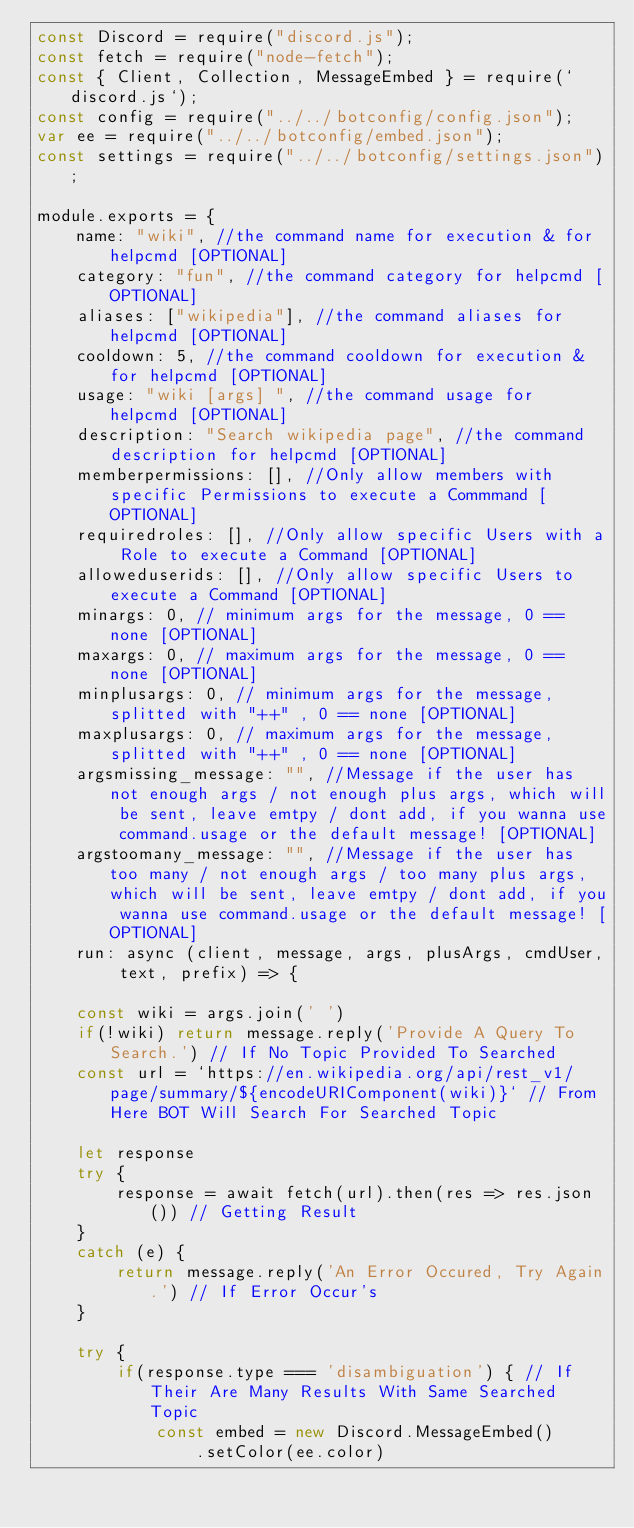Convert code to text. <code><loc_0><loc_0><loc_500><loc_500><_JavaScript_>const Discord = require("discord.js");
const fetch = require("node-fetch");
const { Client, Collection, MessageEmbed } = require(`discord.js`);
const config = require("../../botconfig/config.json");
var ee = require("../../botconfig/embed.json");
const settings = require("../../botconfig/settings.json");

module.exports = {
    name: "wiki", //the command name for execution & for helpcmd [OPTIONAL]
    category: "fun", //the command category for helpcmd [OPTIONAL]
    aliases: ["wikipedia"], //the command aliases for helpcmd [OPTIONAL]
    cooldown: 5, //the command cooldown for execution & for helpcmd [OPTIONAL]
    usage: "wiki [args] ", //the command usage for helpcmd [OPTIONAL]
    description: "Search wikipedia page", //the command description for helpcmd [OPTIONAL]
    memberpermissions: [], //Only allow members with specific Permissions to execute a Commmand [OPTIONAL]
    requiredroles: [], //Only allow specific Users with a Role to execute a Command [OPTIONAL]
    alloweduserids: [], //Only allow specific Users to execute a Command [OPTIONAL]
    minargs: 0, // minimum args for the message, 0 == none [OPTIONAL]
    maxargs: 0, // maximum args for the message, 0 == none [OPTIONAL]
    minplusargs: 0, // minimum args for the message, splitted with "++" , 0 == none [OPTIONAL]
    maxplusargs: 0, // maximum args for the message, splitted with "++" , 0 == none [OPTIONAL]
    argsmissing_message: "", //Message if the user has not enough args / not enough plus args, which will be sent, leave emtpy / dont add, if you wanna use command.usage or the default message! [OPTIONAL]
    argstoomany_message: "", //Message if the user has too many / not enough args / too many plus args, which will be sent, leave emtpy / dont add, if you wanna use command.usage or the default message! [OPTIONAL]
    run: async (client, message, args, plusArgs, cmdUser, text, prefix) => {
    
    const wiki = args.join(' ')
    if(!wiki) return message.reply('Provide A Query To Search.') // If No Topic Provided To Searched
    const url = `https://en.wikipedia.org/api/rest_v1/page/summary/${encodeURIComponent(wiki)}` // From Here BOT Will Search For Searched Topic

    let response
    try {
        response = await fetch(url).then(res => res.json()) // Getting Result
    }
    catch (e) {
        return message.reply('An Error Occured, Try Again.') // If Error Occur's
    }

    try {
        if(response.type === 'disambiguation') { // If Their Are Many Results With Same Searched Topic
            const embed = new Discord.MessageEmbed()
                .setColor(ee.color)</code> 